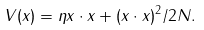<formula> <loc_0><loc_0><loc_500><loc_500>V ( { x } ) = \eta { x } \cdot { x } + ( { x } \cdot { x } ) ^ { 2 } / 2 N .</formula> 